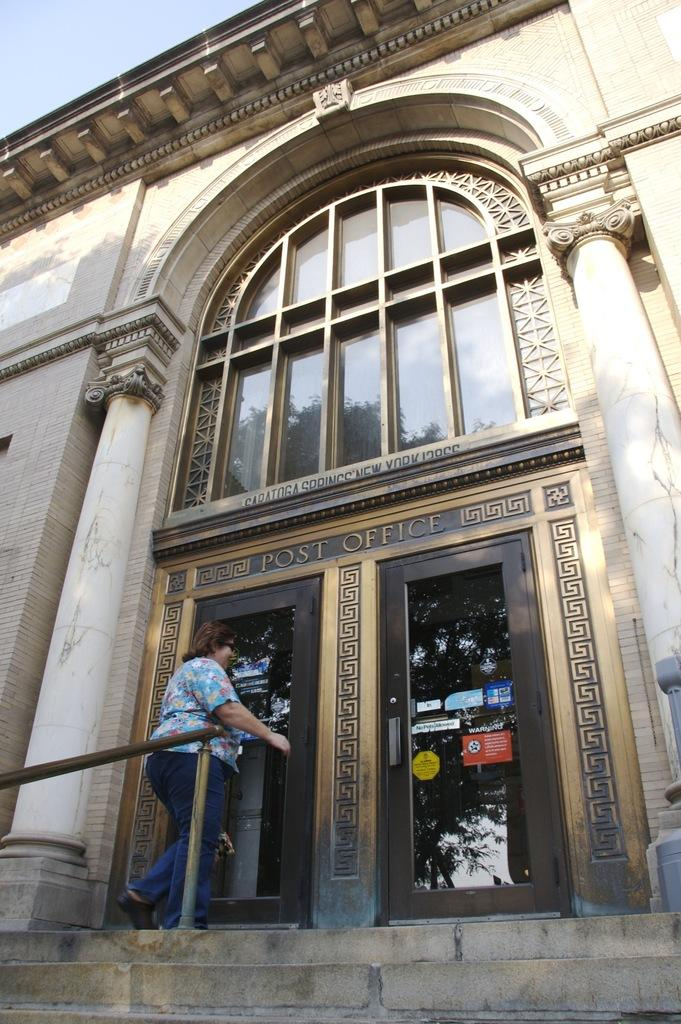What is the person at the entrance of the building doing? The person is standing at the entrance of the building. What can be seen in the image besides the person? There is a fence and stairs visible in the image. What is written or displayed at the front of the building? There is a name at the front of the building. How many boys are wearing apparel in the image? There are no boys or apparel mentioned in the image; it only features a person standing at the entrance of a building. What type of cat can be seen playing with the fence in the image? There is no cat present in the image, and therefore no such activity can be observed. 